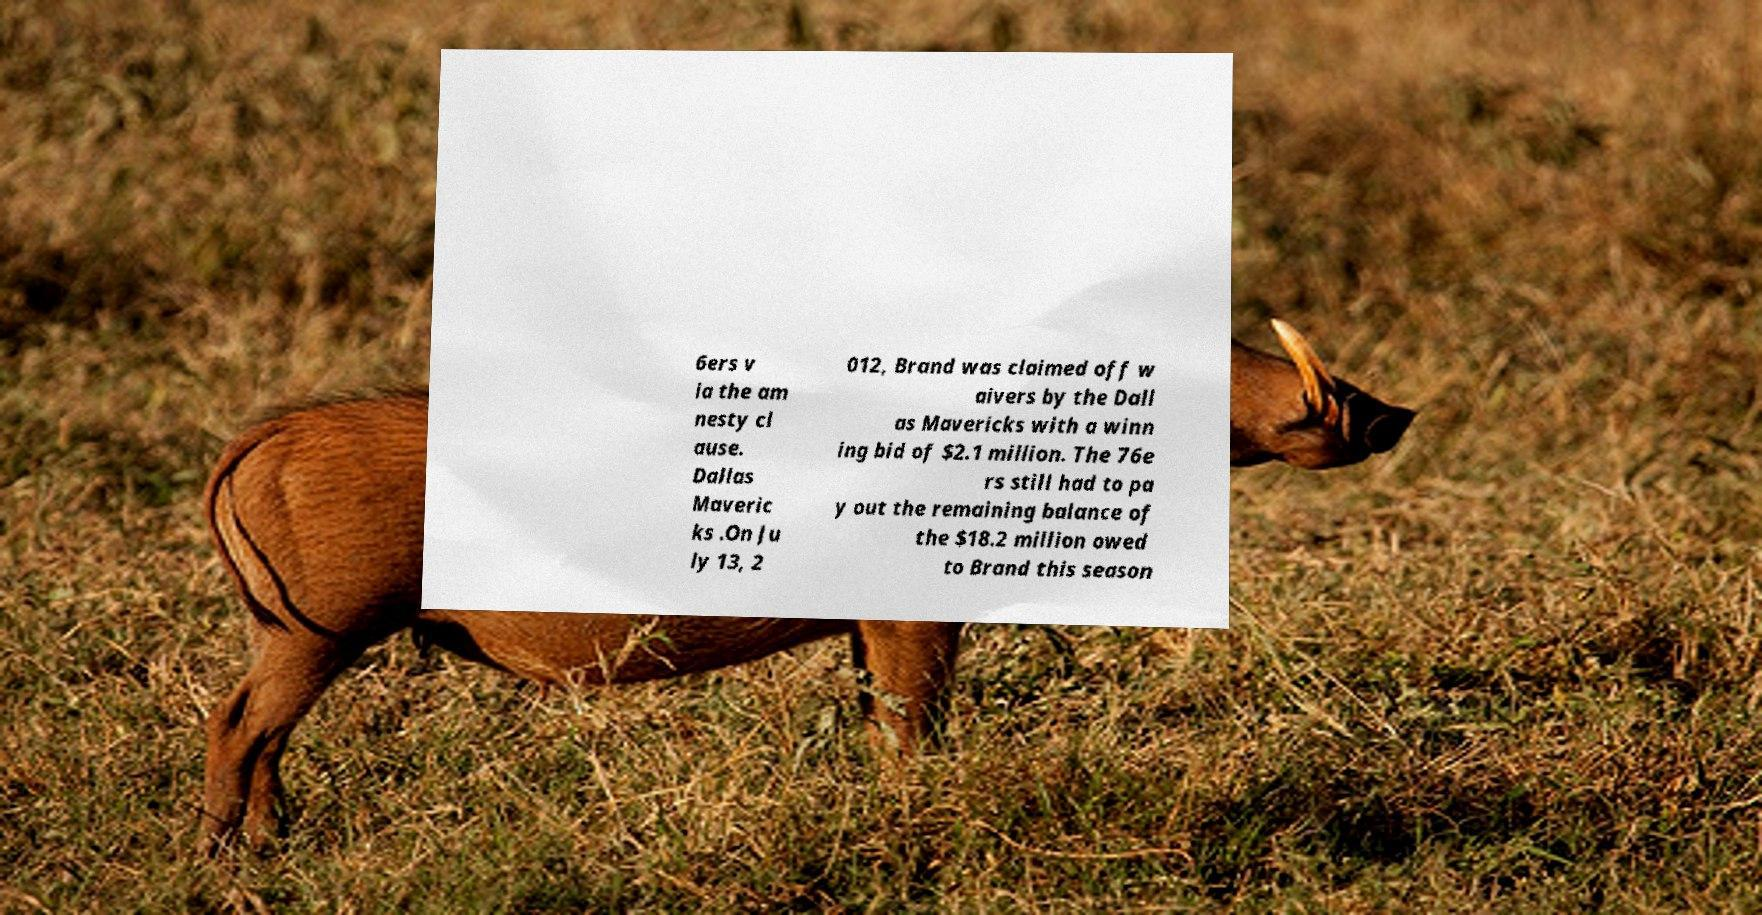Please identify and transcribe the text found in this image. 6ers v ia the am nesty cl ause. Dallas Maveric ks .On Ju ly 13, 2 012, Brand was claimed off w aivers by the Dall as Mavericks with a winn ing bid of $2.1 million. The 76e rs still had to pa y out the remaining balance of the $18.2 million owed to Brand this season 